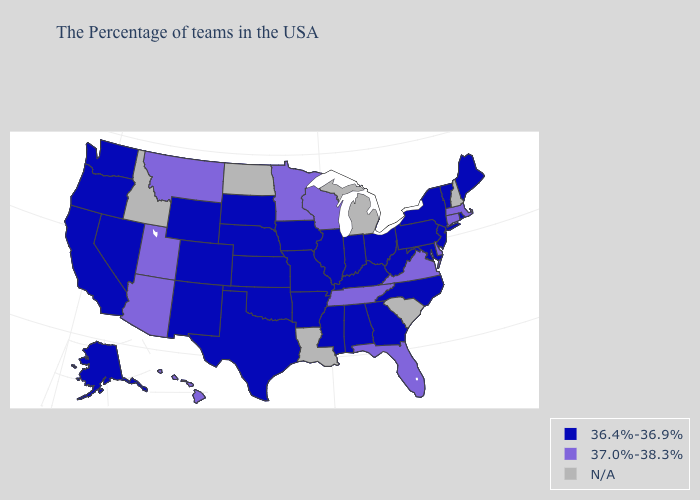Among the states that border West Virginia , which have the highest value?
Write a very short answer. Virginia. Name the states that have a value in the range N/A?
Answer briefly. New Hampshire, South Carolina, Michigan, Louisiana, North Dakota, Idaho. Name the states that have a value in the range 37.0%-38.3%?
Give a very brief answer. Massachusetts, Connecticut, Delaware, Virginia, Florida, Tennessee, Wisconsin, Minnesota, Utah, Montana, Arizona, Hawaii. What is the value of Florida?
Quick response, please. 37.0%-38.3%. Does Florida have the highest value in the USA?
Answer briefly. Yes. Does the first symbol in the legend represent the smallest category?
Concise answer only. Yes. Does the first symbol in the legend represent the smallest category?
Answer briefly. Yes. Does Rhode Island have the lowest value in the USA?
Keep it brief. Yes. Does Wisconsin have the lowest value in the MidWest?
Write a very short answer. No. What is the value of Texas?
Concise answer only. 36.4%-36.9%. Does Iowa have the lowest value in the USA?
Answer briefly. Yes. Does the map have missing data?
Write a very short answer. Yes. Name the states that have a value in the range 37.0%-38.3%?
Concise answer only. Massachusetts, Connecticut, Delaware, Virginia, Florida, Tennessee, Wisconsin, Minnesota, Utah, Montana, Arizona, Hawaii. What is the value of Delaware?
Give a very brief answer. 37.0%-38.3%. Which states have the lowest value in the USA?
Quick response, please. Maine, Rhode Island, Vermont, New York, New Jersey, Maryland, Pennsylvania, North Carolina, West Virginia, Ohio, Georgia, Kentucky, Indiana, Alabama, Illinois, Mississippi, Missouri, Arkansas, Iowa, Kansas, Nebraska, Oklahoma, Texas, South Dakota, Wyoming, Colorado, New Mexico, Nevada, California, Washington, Oregon, Alaska. 